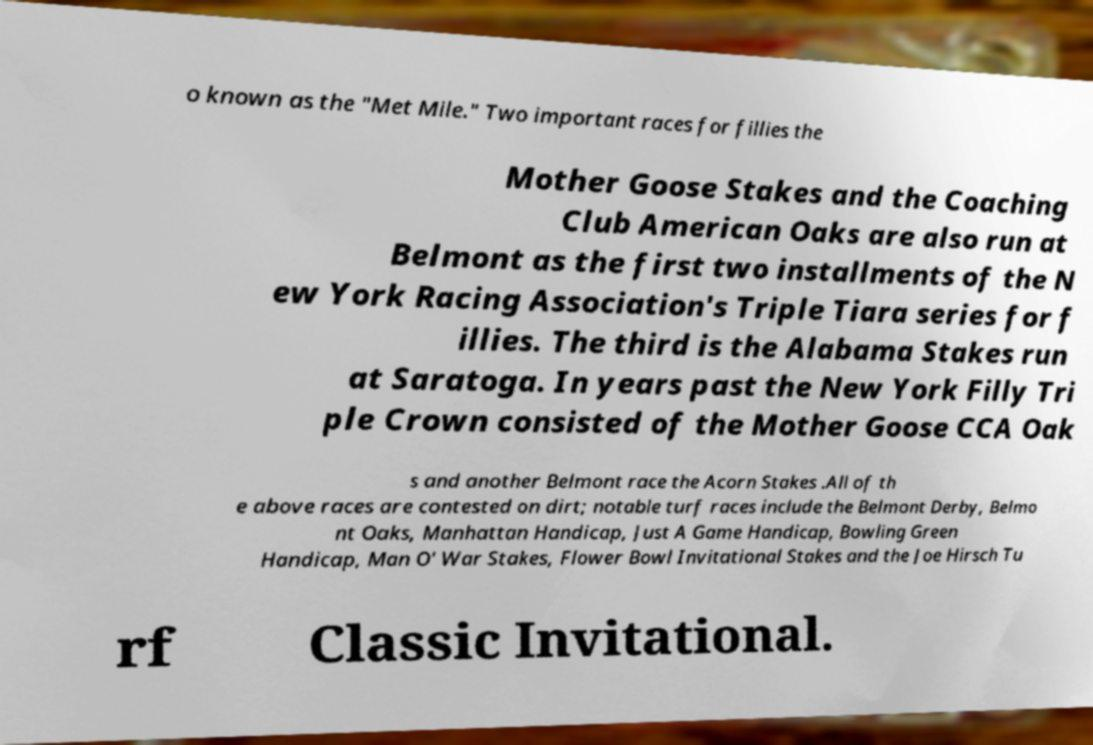Can you accurately transcribe the text from the provided image for me? o known as the "Met Mile." Two important races for fillies the Mother Goose Stakes and the Coaching Club American Oaks are also run at Belmont as the first two installments of the N ew York Racing Association's Triple Tiara series for f illies. The third is the Alabama Stakes run at Saratoga. In years past the New York Filly Tri ple Crown consisted of the Mother Goose CCA Oak s and another Belmont race the Acorn Stakes .All of th e above races are contested on dirt; notable turf races include the Belmont Derby, Belmo nt Oaks, Manhattan Handicap, Just A Game Handicap, Bowling Green Handicap, Man O' War Stakes, Flower Bowl Invitational Stakes and the Joe Hirsch Tu rf Classic Invitational. 